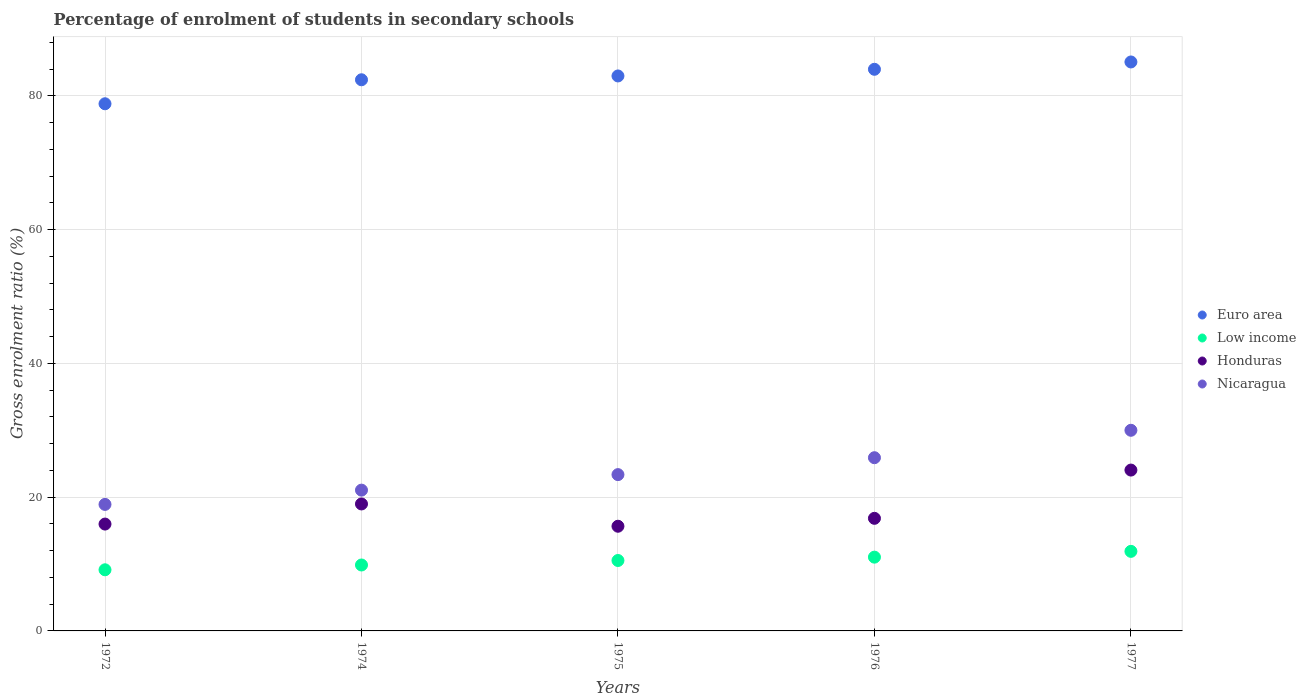How many different coloured dotlines are there?
Your response must be concise. 4. What is the percentage of students enrolled in secondary schools in Nicaragua in 1977?
Keep it short and to the point. 30. Across all years, what is the maximum percentage of students enrolled in secondary schools in Nicaragua?
Ensure brevity in your answer.  30. Across all years, what is the minimum percentage of students enrolled in secondary schools in Nicaragua?
Give a very brief answer. 18.91. What is the total percentage of students enrolled in secondary schools in Low income in the graph?
Provide a succinct answer. 52.45. What is the difference between the percentage of students enrolled in secondary schools in Euro area in 1972 and that in 1976?
Your response must be concise. -5.15. What is the difference between the percentage of students enrolled in secondary schools in Nicaragua in 1975 and the percentage of students enrolled in secondary schools in Honduras in 1974?
Your answer should be very brief. 4.39. What is the average percentage of students enrolled in secondary schools in Euro area per year?
Offer a very short reply. 82.64. In the year 1975, what is the difference between the percentage of students enrolled in secondary schools in Euro area and percentage of students enrolled in secondary schools in Nicaragua?
Give a very brief answer. 59.6. In how many years, is the percentage of students enrolled in secondary schools in Nicaragua greater than 48 %?
Offer a very short reply. 0. What is the ratio of the percentage of students enrolled in secondary schools in Euro area in 1972 to that in 1975?
Make the answer very short. 0.95. Is the percentage of students enrolled in secondary schools in Nicaragua in 1974 less than that in 1976?
Make the answer very short. Yes. Is the difference between the percentage of students enrolled in secondary schools in Euro area in 1976 and 1977 greater than the difference between the percentage of students enrolled in secondary schools in Nicaragua in 1976 and 1977?
Offer a terse response. Yes. What is the difference between the highest and the second highest percentage of students enrolled in secondary schools in Honduras?
Make the answer very short. 5.06. What is the difference between the highest and the lowest percentage of students enrolled in secondary schools in Euro area?
Keep it short and to the point. 6.25. Is it the case that in every year, the sum of the percentage of students enrolled in secondary schools in Low income and percentage of students enrolled in secondary schools in Nicaragua  is greater than the percentage of students enrolled in secondary schools in Honduras?
Your answer should be very brief. Yes. Does the percentage of students enrolled in secondary schools in Euro area monotonically increase over the years?
Provide a succinct answer. Yes. Is the percentage of students enrolled in secondary schools in Nicaragua strictly greater than the percentage of students enrolled in secondary schools in Low income over the years?
Provide a short and direct response. Yes. Is the percentage of students enrolled in secondary schools in Honduras strictly less than the percentage of students enrolled in secondary schools in Nicaragua over the years?
Your answer should be compact. Yes. How many dotlines are there?
Provide a short and direct response. 4. How many years are there in the graph?
Ensure brevity in your answer.  5. What is the difference between two consecutive major ticks on the Y-axis?
Offer a very short reply. 20. Does the graph contain any zero values?
Give a very brief answer. No. Does the graph contain grids?
Make the answer very short. Yes. Where does the legend appear in the graph?
Give a very brief answer. Center right. How are the legend labels stacked?
Keep it short and to the point. Vertical. What is the title of the graph?
Your response must be concise. Percentage of enrolment of students in secondary schools. Does "Fragile and conflict affected situations" appear as one of the legend labels in the graph?
Give a very brief answer. No. What is the label or title of the Y-axis?
Offer a very short reply. Gross enrolment ratio (%). What is the Gross enrolment ratio (%) of Euro area in 1972?
Offer a terse response. 78.81. What is the Gross enrolment ratio (%) of Low income in 1972?
Ensure brevity in your answer.  9.14. What is the Gross enrolment ratio (%) in Honduras in 1972?
Provide a succinct answer. 15.97. What is the Gross enrolment ratio (%) of Nicaragua in 1972?
Keep it short and to the point. 18.91. What is the Gross enrolment ratio (%) in Euro area in 1974?
Give a very brief answer. 82.4. What is the Gross enrolment ratio (%) of Low income in 1974?
Offer a terse response. 9.86. What is the Gross enrolment ratio (%) of Honduras in 1974?
Provide a short and direct response. 18.98. What is the Gross enrolment ratio (%) of Nicaragua in 1974?
Make the answer very short. 21.05. What is the Gross enrolment ratio (%) in Euro area in 1975?
Provide a short and direct response. 82.97. What is the Gross enrolment ratio (%) in Low income in 1975?
Provide a short and direct response. 10.53. What is the Gross enrolment ratio (%) of Honduras in 1975?
Your response must be concise. 15.65. What is the Gross enrolment ratio (%) in Nicaragua in 1975?
Give a very brief answer. 23.37. What is the Gross enrolment ratio (%) in Euro area in 1976?
Your answer should be very brief. 83.96. What is the Gross enrolment ratio (%) in Low income in 1976?
Your response must be concise. 11.03. What is the Gross enrolment ratio (%) in Honduras in 1976?
Give a very brief answer. 16.83. What is the Gross enrolment ratio (%) in Nicaragua in 1976?
Ensure brevity in your answer.  25.89. What is the Gross enrolment ratio (%) in Euro area in 1977?
Keep it short and to the point. 85.06. What is the Gross enrolment ratio (%) of Low income in 1977?
Your response must be concise. 11.89. What is the Gross enrolment ratio (%) in Honduras in 1977?
Provide a short and direct response. 24.05. What is the Gross enrolment ratio (%) in Nicaragua in 1977?
Your answer should be very brief. 30. Across all years, what is the maximum Gross enrolment ratio (%) of Euro area?
Offer a terse response. 85.06. Across all years, what is the maximum Gross enrolment ratio (%) of Low income?
Give a very brief answer. 11.89. Across all years, what is the maximum Gross enrolment ratio (%) of Honduras?
Your answer should be very brief. 24.05. Across all years, what is the maximum Gross enrolment ratio (%) in Nicaragua?
Offer a terse response. 30. Across all years, what is the minimum Gross enrolment ratio (%) of Euro area?
Your answer should be compact. 78.81. Across all years, what is the minimum Gross enrolment ratio (%) in Low income?
Your response must be concise. 9.14. Across all years, what is the minimum Gross enrolment ratio (%) of Honduras?
Make the answer very short. 15.65. Across all years, what is the minimum Gross enrolment ratio (%) in Nicaragua?
Your response must be concise. 18.91. What is the total Gross enrolment ratio (%) of Euro area in the graph?
Provide a succinct answer. 413.19. What is the total Gross enrolment ratio (%) in Low income in the graph?
Provide a short and direct response. 52.45. What is the total Gross enrolment ratio (%) of Honduras in the graph?
Offer a terse response. 91.48. What is the total Gross enrolment ratio (%) in Nicaragua in the graph?
Offer a terse response. 119.22. What is the difference between the Gross enrolment ratio (%) of Euro area in 1972 and that in 1974?
Keep it short and to the point. -3.59. What is the difference between the Gross enrolment ratio (%) of Low income in 1972 and that in 1974?
Give a very brief answer. -0.72. What is the difference between the Gross enrolment ratio (%) of Honduras in 1972 and that in 1974?
Provide a short and direct response. -3.01. What is the difference between the Gross enrolment ratio (%) in Nicaragua in 1972 and that in 1974?
Your response must be concise. -2.13. What is the difference between the Gross enrolment ratio (%) of Euro area in 1972 and that in 1975?
Give a very brief answer. -4.16. What is the difference between the Gross enrolment ratio (%) of Low income in 1972 and that in 1975?
Offer a terse response. -1.39. What is the difference between the Gross enrolment ratio (%) in Honduras in 1972 and that in 1975?
Make the answer very short. 0.32. What is the difference between the Gross enrolment ratio (%) in Nicaragua in 1972 and that in 1975?
Ensure brevity in your answer.  -4.45. What is the difference between the Gross enrolment ratio (%) of Euro area in 1972 and that in 1976?
Provide a short and direct response. -5.15. What is the difference between the Gross enrolment ratio (%) in Low income in 1972 and that in 1976?
Offer a terse response. -1.89. What is the difference between the Gross enrolment ratio (%) of Honduras in 1972 and that in 1976?
Make the answer very short. -0.86. What is the difference between the Gross enrolment ratio (%) of Nicaragua in 1972 and that in 1976?
Give a very brief answer. -6.98. What is the difference between the Gross enrolment ratio (%) in Euro area in 1972 and that in 1977?
Make the answer very short. -6.25. What is the difference between the Gross enrolment ratio (%) of Low income in 1972 and that in 1977?
Your answer should be compact. -2.76. What is the difference between the Gross enrolment ratio (%) in Honduras in 1972 and that in 1977?
Your response must be concise. -8.07. What is the difference between the Gross enrolment ratio (%) of Nicaragua in 1972 and that in 1977?
Keep it short and to the point. -11.08. What is the difference between the Gross enrolment ratio (%) of Euro area in 1974 and that in 1975?
Ensure brevity in your answer.  -0.57. What is the difference between the Gross enrolment ratio (%) of Low income in 1974 and that in 1975?
Provide a short and direct response. -0.67. What is the difference between the Gross enrolment ratio (%) in Honduras in 1974 and that in 1975?
Your answer should be very brief. 3.33. What is the difference between the Gross enrolment ratio (%) in Nicaragua in 1974 and that in 1975?
Your answer should be very brief. -2.32. What is the difference between the Gross enrolment ratio (%) of Euro area in 1974 and that in 1976?
Offer a very short reply. -1.57. What is the difference between the Gross enrolment ratio (%) of Low income in 1974 and that in 1976?
Make the answer very short. -1.17. What is the difference between the Gross enrolment ratio (%) in Honduras in 1974 and that in 1976?
Your response must be concise. 2.15. What is the difference between the Gross enrolment ratio (%) in Nicaragua in 1974 and that in 1976?
Offer a very short reply. -4.85. What is the difference between the Gross enrolment ratio (%) in Euro area in 1974 and that in 1977?
Provide a short and direct response. -2.66. What is the difference between the Gross enrolment ratio (%) of Low income in 1974 and that in 1977?
Keep it short and to the point. -2.04. What is the difference between the Gross enrolment ratio (%) of Honduras in 1974 and that in 1977?
Keep it short and to the point. -5.06. What is the difference between the Gross enrolment ratio (%) in Nicaragua in 1974 and that in 1977?
Provide a short and direct response. -8.95. What is the difference between the Gross enrolment ratio (%) in Euro area in 1975 and that in 1976?
Provide a short and direct response. -1. What is the difference between the Gross enrolment ratio (%) of Low income in 1975 and that in 1976?
Offer a very short reply. -0.5. What is the difference between the Gross enrolment ratio (%) in Honduras in 1975 and that in 1976?
Your response must be concise. -1.18. What is the difference between the Gross enrolment ratio (%) of Nicaragua in 1975 and that in 1976?
Give a very brief answer. -2.53. What is the difference between the Gross enrolment ratio (%) in Euro area in 1975 and that in 1977?
Offer a very short reply. -2.09. What is the difference between the Gross enrolment ratio (%) of Low income in 1975 and that in 1977?
Keep it short and to the point. -1.37. What is the difference between the Gross enrolment ratio (%) in Honduras in 1975 and that in 1977?
Your response must be concise. -8.4. What is the difference between the Gross enrolment ratio (%) in Nicaragua in 1975 and that in 1977?
Your answer should be compact. -6.63. What is the difference between the Gross enrolment ratio (%) in Euro area in 1976 and that in 1977?
Your answer should be compact. -1.09. What is the difference between the Gross enrolment ratio (%) in Low income in 1976 and that in 1977?
Ensure brevity in your answer.  -0.87. What is the difference between the Gross enrolment ratio (%) in Honduras in 1976 and that in 1977?
Your response must be concise. -7.21. What is the difference between the Gross enrolment ratio (%) of Nicaragua in 1976 and that in 1977?
Ensure brevity in your answer.  -4.1. What is the difference between the Gross enrolment ratio (%) in Euro area in 1972 and the Gross enrolment ratio (%) in Low income in 1974?
Provide a short and direct response. 68.95. What is the difference between the Gross enrolment ratio (%) in Euro area in 1972 and the Gross enrolment ratio (%) in Honduras in 1974?
Give a very brief answer. 59.83. What is the difference between the Gross enrolment ratio (%) in Euro area in 1972 and the Gross enrolment ratio (%) in Nicaragua in 1974?
Offer a terse response. 57.76. What is the difference between the Gross enrolment ratio (%) of Low income in 1972 and the Gross enrolment ratio (%) of Honduras in 1974?
Keep it short and to the point. -9.84. What is the difference between the Gross enrolment ratio (%) in Low income in 1972 and the Gross enrolment ratio (%) in Nicaragua in 1974?
Give a very brief answer. -11.91. What is the difference between the Gross enrolment ratio (%) in Honduras in 1972 and the Gross enrolment ratio (%) in Nicaragua in 1974?
Your answer should be very brief. -5.07. What is the difference between the Gross enrolment ratio (%) of Euro area in 1972 and the Gross enrolment ratio (%) of Low income in 1975?
Provide a succinct answer. 68.28. What is the difference between the Gross enrolment ratio (%) of Euro area in 1972 and the Gross enrolment ratio (%) of Honduras in 1975?
Offer a very short reply. 63.16. What is the difference between the Gross enrolment ratio (%) in Euro area in 1972 and the Gross enrolment ratio (%) in Nicaragua in 1975?
Provide a short and direct response. 55.44. What is the difference between the Gross enrolment ratio (%) in Low income in 1972 and the Gross enrolment ratio (%) in Honduras in 1975?
Ensure brevity in your answer.  -6.51. What is the difference between the Gross enrolment ratio (%) in Low income in 1972 and the Gross enrolment ratio (%) in Nicaragua in 1975?
Ensure brevity in your answer.  -14.23. What is the difference between the Gross enrolment ratio (%) of Honduras in 1972 and the Gross enrolment ratio (%) of Nicaragua in 1975?
Keep it short and to the point. -7.39. What is the difference between the Gross enrolment ratio (%) of Euro area in 1972 and the Gross enrolment ratio (%) of Low income in 1976?
Provide a short and direct response. 67.78. What is the difference between the Gross enrolment ratio (%) of Euro area in 1972 and the Gross enrolment ratio (%) of Honduras in 1976?
Ensure brevity in your answer.  61.98. What is the difference between the Gross enrolment ratio (%) of Euro area in 1972 and the Gross enrolment ratio (%) of Nicaragua in 1976?
Provide a short and direct response. 52.91. What is the difference between the Gross enrolment ratio (%) in Low income in 1972 and the Gross enrolment ratio (%) in Honduras in 1976?
Offer a very short reply. -7.69. What is the difference between the Gross enrolment ratio (%) in Low income in 1972 and the Gross enrolment ratio (%) in Nicaragua in 1976?
Keep it short and to the point. -16.76. What is the difference between the Gross enrolment ratio (%) of Honduras in 1972 and the Gross enrolment ratio (%) of Nicaragua in 1976?
Your answer should be very brief. -9.92. What is the difference between the Gross enrolment ratio (%) in Euro area in 1972 and the Gross enrolment ratio (%) in Low income in 1977?
Make the answer very short. 66.91. What is the difference between the Gross enrolment ratio (%) of Euro area in 1972 and the Gross enrolment ratio (%) of Honduras in 1977?
Offer a very short reply. 54.76. What is the difference between the Gross enrolment ratio (%) in Euro area in 1972 and the Gross enrolment ratio (%) in Nicaragua in 1977?
Offer a terse response. 48.81. What is the difference between the Gross enrolment ratio (%) of Low income in 1972 and the Gross enrolment ratio (%) of Honduras in 1977?
Your response must be concise. -14.91. What is the difference between the Gross enrolment ratio (%) in Low income in 1972 and the Gross enrolment ratio (%) in Nicaragua in 1977?
Provide a short and direct response. -20.86. What is the difference between the Gross enrolment ratio (%) of Honduras in 1972 and the Gross enrolment ratio (%) of Nicaragua in 1977?
Offer a very short reply. -14.02. What is the difference between the Gross enrolment ratio (%) in Euro area in 1974 and the Gross enrolment ratio (%) in Low income in 1975?
Offer a very short reply. 71.87. What is the difference between the Gross enrolment ratio (%) of Euro area in 1974 and the Gross enrolment ratio (%) of Honduras in 1975?
Ensure brevity in your answer.  66.75. What is the difference between the Gross enrolment ratio (%) of Euro area in 1974 and the Gross enrolment ratio (%) of Nicaragua in 1975?
Your answer should be compact. 59.03. What is the difference between the Gross enrolment ratio (%) in Low income in 1974 and the Gross enrolment ratio (%) in Honduras in 1975?
Give a very brief answer. -5.79. What is the difference between the Gross enrolment ratio (%) of Low income in 1974 and the Gross enrolment ratio (%) of Nicaragua in 1975?
Provide a short and direct response. -13.51. What is the difference between the Gross enrolment ratio (%) of Honduras in 1974 and the Gross enrolment ratio (%) of Nicaragua in 1975?
Ensure brevity in your answer.  -4.39. What is the difference between the Gross enrolment ratio (%) of Euro area in 1974 and the Gross enrolment ratio (%) of Low income in 1976?
Provide a succinct answer. 71.37. What is the difference between the Gross enrolment ratio (%) of Euro area in 1974 and the Gross enrolment ratio (%) of Honduras in 1976?
Ensure brevity in your answer.  65.56. What is the difference between the Gross enrolment ratio (%) in Euro area in 1974 and the Gross enrolment ratio (%) in Nicaragua in 1976?
Offer a terse response. 56.5. What is the difference between the Gross enrolment ratio (%) of Low income in 1974 and the Gross enrolment ratio (%) of Honduras in 1976?
Your answer should be very brief. -6.98. What is the difference between the Gross enrolment ratio (%) in Low income in 1974 and the Gross enrolment ratio (%) in Nicaragua in 1976?
Offer a terse response. -16.04. What is the difference between the Gross enrolment ratio (%) of Honduras in 1974 and the Gross enrolment ratio (%) of Nicaragua in 1976?
Make the answer very short. -6.91. What is the difference between the Gross enrolment ratio (%) in Euro area in 1974 and the Gross enrolment ratio (%) in Low income in 1977?
Make the answer very short. 70.5. What is the difference between the Gross enrolment ratio (%) of Euro area in 1974 and the Gross enrolment ratio (%) of Honduras in 1977?
Ensure brevity in your answer.  58.35. What is the difference between the Gross enrolment ratio (%) of Euro area in 1974 and the Gross enrolment ratio (%) of Nicaragua in 1977?
Offer a terse response. 52.4. What is the difference between the Gross enrolment ratio (%) in Low income in 1974 and the Gross enrolment ratio (%) in Honduras in 1977?
Your answer should be very brief. -14.19. What is the difference between the Gross enrolment ratio (%) of Low income in 1974 and the Gross enrolment ratio (%) of Nicaragua in 1977?
Ensure brevity in your answer.  -20.14. What is the difference between the Gross enrolment ratio (%) in Honduras in 1974 and the Gross enrolment ratio (%) in Nicaragua in 1977?
Your answer should be compact. -11.01. What is the difference between the Gross enrolment ratio (%) of Euro area in 1975 and the Gross enrolment ratio (%) of Low income in 1976?
Offer a terse response. 71.94. What is the difference between the Gross enrolment ratio (%) in Euro area in 1975 and the Gross enrolment ratio (%) in Honduras in 1976?
Keep it short and to the point. 66.13. What is the difference between the Gross enrolment ratio (%) of Euro area in 1975 and the Gross enrolment ratio (%) of Nicaragua in 1976?
Your response must be concise. 57.07. What is the difference between the Gross enrolment ratio (%) in Low income in 1975 and the Gross enrolment ratio (%) in Honduras in 1976?
Ensure brevity in your answer.  -6.3. What is the difference between the Gross enrolment ratio (%) in Low income in 1975 and the Gross enrolment ratio (%) in Nicaragua in 1976?
Ensure brevity in your answer.  -15.37. What is the difference between the Gross enrolment ratio (%) of Honduras in 1975 and the Gross enrolment ratio (%) of Nicaragua in 1976?
Your response must be concise. -10.24. What is the difference between the Gross enrolment ratio (%) in Euro area in 1975 and the Gross enrolment ratio (%) in Low income in 1977?
Ensure brevity in your answer.  71.07. What is the difference between the Gross enrolment ratio (%) in Euro area in 1975 and the Gross enrolment ratio (%) in Honduras in 1977?
Keep it short and to the point. 58.92. What is the difference between the Gross enrolment ratio (%) of Euro area in 1975 and the Gross enrolment ratio (%) of Nicaragua in 1977?
Provide a succinct answer. 52.97. What is the difference between the Gross enrolment ratio (%) in Low income in 1975 and the Gross enrolment ratio (%) in Honduras in 1977?
Keep it short and to the point. -13.52. What is the difference between the Gross enrolment ratio (%) in Low income in 1975 and the Gross enrolment ratio (%) in Nicaragua in 1977?
Provide a short and direct response. -19.47. What is the difference between the Gross enrolment ratio (%) of Honduras in 1975 and the Gross enrolment ratio (%) of Nicaragua in 1977?
Make the answer very short. -14.35. What is the difference between the Gross enrolment ratio (%) in Euro area in 1976 and the Gross enrolment ratio (%) in Low income in 1977?
Keep it short and to the point. 72.07. What is the difference between the Gross enrolment ratio (%) of Euro area in 1976 and the Gross enrolment ratio (%) of Honduras in 1977?
Offer a terse response. 59.92. What is the difference between the Gross enrolment ratio (%) in Euro area in 1976 and the Gross enrolment ratio (%) in Nicaragua in 1977?
Offer a very short reply. 53.97. What is the difference between the Gross enrolment ratio (%) in Low income in 1976 and the Gross enrolment ratio (%) in Honduras in 1977?
Provide a succinct answer. -13.02. What is the difference between the Gross enrolment ratio (%) of Low income in 1976 and the Gross enrolment ratio (%) of Nicaragua in 1977?
Provide a short and direct response. -18.97. What is the difference between the Gross enrolment ratio (%) of Honduras in 1976 and the Gross enrolment ratio (%) of Nicaragua in 1977?
Make the answer very short. -13.16. What is the average Gross enrolment ratio (%) of Euro area per year?
Your answer should be compact. 82.64. What is the average Gross enrolment ratio (%) in Low income per year?
Give a very brief answer. 10.49. What is the average Gross enrolment ratio (%) of Honduras per year?
Give a very brief answer. 18.3. What is the average Gross enrolment ratio (%) of Nicaragua per year?
Your answer should be compact. 23.84. In the year 1972, what is the difference between the Gross enrolment ratio (%) in Euro area and Gross enrolment ratio (%) in Low income?
Ensure brevity in your answer.  69.67. In the year 1972, what is the difference between the Gross enrolment ratio (%) in Euro area and Gross enrolment ratio (%) in Honduras?
Provide a succinct answer. 62.83. In the year 1972, what is the difference between the Gross enrolment ratio (%) in Euro area and Gross enrolment ratio (%) in Nicaragua?
Make the answer very short. 59.89. In the year 1972, what is the difference between the Gross enrolment ratio (%) of Low income and Gross enrolment ratio (%) of Honduras?
Offer a very short reply. -6.83. In the year 1972, what is the difference between the Gross enrolment ratio (%) of Low income and Gross enrolment ratio (%) of Nicaragua?
Your answer should be very brief. -9.77. In the year 1972, what is the difference between the Gross enrolment ratio (%) in Honduras and Gross enrolment ratio (%) in Nicaragua?
Ensure brevity in your answer.  -2.94. In the year 1974, what is the difference between the Gross enrolment ratio (%) in Euro area and Gross enrolment ratio (%) in Low income?
Make the answer very short. 72.54. In the year 1974, what is the difference between the Gross enrolment ratio (%) in Euro area and Gross enrolment ratio (%) in Honduras?
Offer a terse response. 63.41. In the year 1974, what is the difference between the Gross enrolment ratio (%) in Euro area and Gross enrolment ratio (%) in Nicaragua?
Provide a short and direct response. 61.35. In the year 1974, what is the difference between the Gross enrolment ratio (%) of Low income and Gross enrolment ratio (%) of Honduras?
Your answer should be compact. -9.13. In the year 1974, what is the difference between the Gross enrolment ratio (%) of Low income and Gross enrolment ratio (%) of Nicaragua?
Make the answer very short. -11.19. In the year 1974, what is the difference between the Gross enrolment ratio (%) of Honduras and Gross enrolment ratio (%) of Nicaragua?
Give a very brief answer. -2.07. In the year 1975, what is the difference between the Gross enrolment ratio (%) of Euro area and Gross enrolment ratio (%) of Low income?
Provide a succinct answer. 72.44. In the year 1975, what is the difference between the Gross enrolment ratio (%) in Euro area and Gross enrolment ratio (%) in Honduras?
Offer a very short reply. 67.32. In the year 1975, what is the difference between the Gross enrolment ratio (%) of Euro area and Gross enrolment ratio (%) of Nicaragua?
Provide a succinct answer. 59.6. In the year 1975, what is the difference between the Gross enrolment ratio (%) in Low income and Gross enrolment ratio (%) in Honduras?
Keep it short and to the point. -5.12. In the year 1975, what is the difference between the Gross enrolment ratio (%) in Low income and Gross enrolment ratio (%) in Nicaragua?
Offer a very short reply. -12.84. In the year 1975, what is the difference between the Gross enrolment ratio (%) of Honduras and Gross enrolment ratio (%) of Nicaragua?
Offer a very short reply. -7.72. In the year 1976, what is the difference between the Gross enrolment ratio (%) of Euro area and Gross enrolment ratio (%) of Low income?
Keep it short and to the point. 72.93. In the year 1976, what is the difference between the Gross enrolment ratio (%) of Euro area and Gross enrolment ratio (%) of Honduras?
Give a very brief answer. 67.13. In the year 1976, what is the difference between the Gross enrolment ratio (%) in Euro area and Gross enrolment ratio (%) in Nicaragua?
Ensure brevity in your answer.  58.07. In the year 1976, what is the difference between the Gross enrolment ratio (%) of Low income and Gross enrolment ratio (%) of Honduras?
Your answer should be very brief. -5.8. In the year 1976, what is the difference between the Gross enrolment ratio (%) of Low income and Gross enrolment ratio (%) of Nicaragua?
Keep it short and to the point. -14.87. In the year 1976, what is the difference between the Gross enrolment ratio (%) in Honduras and Gross enrolment ratio (%) in Nicaragua?
Make the answer very short. -9.06. In the year 1977, what is the difference between the Gross enrolment ratio (%) of Euro area and Gross enrolment ratio (%) of Low income?
Provide a short and direct response. 73.16. In the year 1977, what is the difference between the Gross enrolment ratio (%) in Euro area and Gross enrolment ratio (%) in Honduras?
Your response must be concise. 61.01. In the year 1977, what is the difference between the Gross enrolment ratio (%) in Euro area and Gross enrolment ratio (%) in Nicaragua?
Keep it short and to the point. 55.06. In the year 1977, what is the difference between the Gross enrolment ratio (%) of Low income and Gross enrolment ratio (%) of Honduras?
Keep it short and to the point. -12.15. In the year 1977, what is the difference between the Gross enrolment ratio (%) in Low income and Gross enrolment ratio (%) in Nicaragua?
Provide a succinct answer. -18.1. In the year 1977, what is the difference between the Gross enrolment ratio (%) in Honduras and Gross enrolment ratio (%) in Nicaragua?
Provide a short and direct response. -5.95. What is the ratio of the Gross enrolment ratio (%) of Euro area in 1972 to that in 1974?
Make the answer very short. 0.96. What is the ratio of the Gross enrolment ratio (%) in Low income in 1972 to that in 1974?
Ensure brevity in your answer.  0.93. What is the ratio of the Gross enrolment ratio (%) in Honduras in 1972 to that in 1974?
Your answer should be compact. 0.84. What is the ratio of the Gross enrolment ratio (%) in Nicaragua in 1972 to that in 1974?
Keep it short and to the point. 0.9. What is the ratio of the Gross enrolment ratio (%) in Euro area in 1972 to that in 1975?
Offer a very short reply. 0.95. What is the ratio of the Gross enrolment ratio (%) of Low income in 1972 to that in 1975?
Ensure brevity in your answer.  0.87. What is the ratio of the Gross enrolment ratio (%) in Honduras in 1972 to that in 1975?
Ensure brevity in your answer.  1.02. What is the ratio of the Gross enrolment ratio (%) in Nicaragua in 1972 to that in 1975?
Offer a terse response. 0.81. What is the ratio of the Gross enrolment ratio (%) in Euro area in 1972 to that in 1976?
Your answer should be compact. 0.94. What is the ratio of the Gross enrolment ratio (%) in Low income in 1972 to that in 1976?
Give a very brief answer. 0.83. What is the ratio of the Gross enrolment ratio (%) in Honduras in 1972 to that in 1976?
Provide a short and direct response. 0.95. What is the ratio of the Gross enrolment ratio (%) in Nicaragua in 1972 to that in 1976?
Provide a succinct answer. 0.73. What is the ratio of the Gross enrolment ratio (%) in Euro area in 1972 to that in 1977?
Offer a terse response. 0.93. What is the ratio of the Gross enrolment ratio (%) of Low income in 1972 to that in 1977?
Give a very brief answer. 0.77. What is the ratio of the Gross enrolment ratio (%) of Honduras in 1972 to that in 1977?
Ensure brevity in your answer.  0.66. What is the ratio of the Gross enrolment ratio (%) in Nicaragua in 1972 to that in 1977?
Offer a terse response. 0.63. What is the ratio of the Gross enrolment ratio (%) in Euro area in 1974 to that in 1975?
Keep it short and to the point. 0.99. What is the ratio of the Gross enrolment ratio (%) of Low income in 1974 to that in 1975?
Ensure brevity in your answer.  0.94. What is the ratio of the Gross enrolment ratio (%) of Honduras in 1974 to that in 1975?
Keep it short and to the point. 1.21. What is the ratio of the Gross enrolment ratio (%) in Nicaragua in 1974 to that in 1975?
Your answer should be compact. 0.9. What is the ratio of the Gross enrolment ratio (%) of Euro area in 1974 to that in 1976?
Offer a terse response. 0.98. What is the ratio of the Gross enrolment ratio (%) in Low income in 1974 to that in 1976?
Your answer should be very brief. 0.89. What is the ratio of the Gross enrolment ratio (%) of Honduras in 1974 to that in 1976?
Offer a very short reply. 1.13. What is the ratio of the Gross enrolment ratio (%) in Nicaragua in 1974 to that in 1976?
Provide a short and direct response. 0.81. What is the ratio of the Gross enrolment ratio (%) of Euro area in 1974 to that in 1977?
Give a very brief answer. 0.97. What is the ratio of the Gross enrolment ratio (%) of Low income in 1974 to that in 1977?
Ensure brevity in your answer.  0.83. What is the ratio of the Gross enrolment ratio (%) of Honduras in 1974 to that in 1977?
Offer a very short reply. 0.79. What is the ratio of the Gross enrolment ratio (%) of Nicaragua in 1974 to that in 1977?
Give a very brief answer. 0.7. What is the ratio of the Gross enrolment ratio (%) of Low income in 1975 to that in 1976?
Your answer should be very brief. 0.95. What is the ratio of the Gross enrolment ratio (%) of Honduras in 1975 to that in 1976?
Your response must be concise. 0.93. What is the ratio of the Gross enrolment ratio (%) of Nicaragua in 1975 to that in 1976?
Your answer should be compact. 0.9. What is the ratio of the Gross enrolment ratio (%) of Euro area in 1975 to that in 1977?
Make the answer very short. 0.98. What is the ratio of the Gross enrolment ratio (%) in Low income in 1975 to that in 1977?
Your answer should be very brief. 0.89. What is the ratio of the Gross enrolment ratio (%) of Honduras in 1975 to that in 1977?
Keep it short and to the point. 0.65. What is the ratio of the Gross enrolment ratio (%) in Nicaragua in 1975 to that in 1977?
Give a very brief answer. 0.78. What is the ratio of the Gross enrolment ratio (%) in Euro area in 1976 to that in 1977?
Provide a short and direct response. 0.99. What is the ratio of the Gross enrolment ratio (%) in Low income in 1976 to that in 1977?
Provide a succinct answer. 0.93. What is the ratio of the Gross enrolment ratio (%) of Nicaragua in 1976 to that in 1977?
Offer a very short reply. 0.86. What is the difference between the highest and the second highest Gross enrolment ratio (%) in Euro area?
Make the answer very short. 1.09. What is the difference between the highest and the second highest Gross enrolment ratio (%) in Low income?
Give a very brief answer. 0.87. What is the difference between the highest and the second highest Gross enrolment ratio (%) of Honduras?
Your response must be concise. 5.06. What is the difference between the highest and the second highest Gross enrolment ratio (%) of Nicaragua?
Your answer should be very brief. 4.1. What is the difference between the highest and the lowest Gross enrolment ratio (%) of Euro area?
Provide a succinct answer. 6.25. What is the difference between the highest and the lowest Gross enrolment ratio (%) in Low income?
Ensure brevity in your answer.  2.76. What is the difference between the highest and the lowest Gross enrolment ratio (%) in Honduras?
Give a very brief answer. 8.4. What is the difference between the highest and the lowest Gross enrolment ratio (%) in Nicaragua?
Your response must be concise. 11.08. 